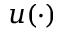Convert formula to latex. <formula><loc_0><loc_0><loc_500><loc_500>u ( \cdot )</formula> 